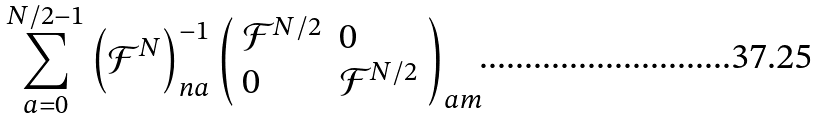<formula> <loc_0><loc_0><loc_500><loc_500>\sum _ { a = 0 } ^ { N / 2 - 1 } \left ( \mathcal { F } ^ { N } \right ) _ { n a } ^ { - 1 } \left ( \begin{array} { l l } \mathcal { F } ^ { N / 2 } & 0 \\ 0 & \mathcal { F } ^ { N / 2 } \end{array} \right ) _ { a m }</formula> 